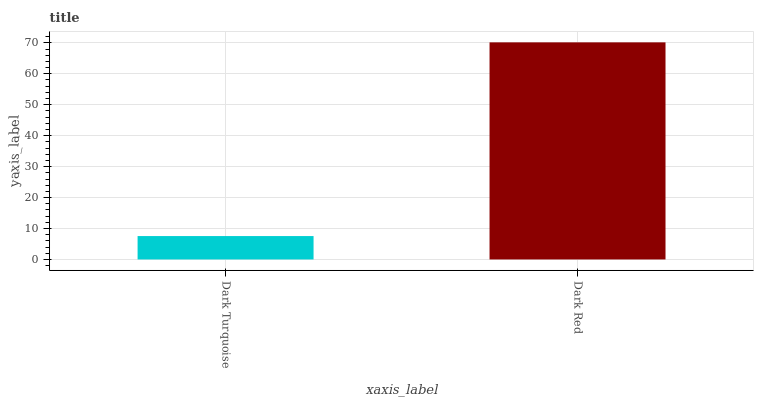Is Dark Turquoise the minimum?
Answer yes or no. Yes. Is Dark Red the maximum?
Answer yes or no. Yes. Is Dark Red the minimum?
Answer yes or no. No. Is Dark Red greater than Dark Turquoise?
Answer yes or no. Yes. Is Dark Turquoise less than Dark Red?
Answer yes or no. Yes. Is Dark Turquoise greater than Dark Red?
Answer yes or no. No. Is Dark Red less than Dark Turquoise?
Answer yes or no. No. Is Dark Red the high median?
Answer yes or no. Yes. Is Dark Turquoise the low median?
Answer yes or no. Yes. Is Dark Turquoise the high median?
Answer yes or no. No. Is Dark Red the low median?
Answer yes or no. No. 